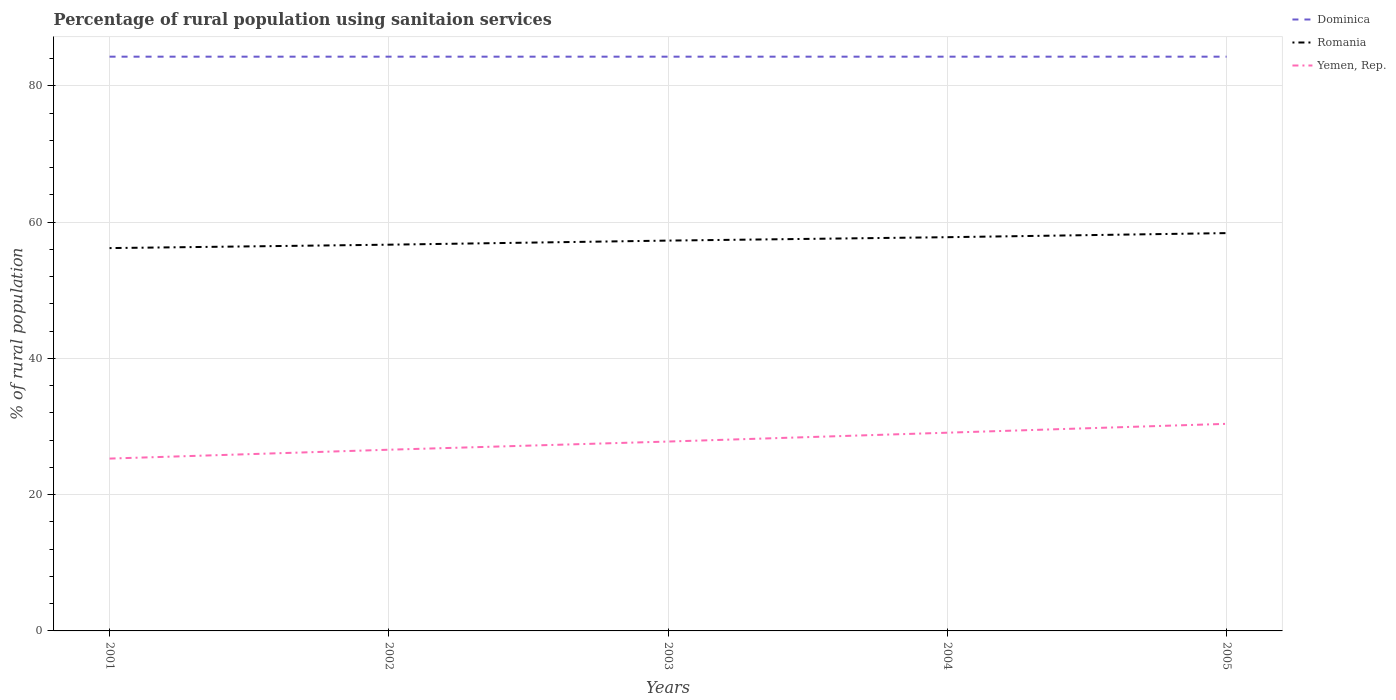Does the line corresponding to Dominica intersect with the line corresponding to Yemen, Rep.?
Your answer should be very brief. No. Is the number of lines equal to the number of legend labels?
Your response must be concise. Yes. Across all years, what is the maximum percentage of rural population using sanitaion services in Dominica?
Your answer should be compact. 84.3. What is the total percentage of rural population using sanitaion services in Yemen, Rep. in the graph?
Offer a very short reply. -3.8. What is the difference between the highest and the second highest percentage of rural population using sanitaion services in Romania?
Give a very brief answer. 2.2. Is the percentage of rural population using sanitaion services in Romania strictly greater than the percentage of rural population using sanitaion services in Yemen, Rep. over the years?
Ensure brevity in your answer.  No. Does the graph contain grids?
Ensure brevity in your answer.  Yes. Where does the legend appear in the graph?
Provide a short and direct response. Top right. How are the legend labels stacked?
Keep it short and to the point. Vertical. What is the title of the graph?
Offer a terse response. Percentage of rural population using sanitaion services. What is the label or title of the X-axis?
Make the answer very short. Years. What is the label or title of the Y-axis?
Your answer should be compact. % of rural population. What is the % of rural population of Dominica in 2001?
Give a very brief answer. 84.3. What is the % of rural population in Romania in 2001?
Offer a terse response. 56.2. What is the % of rural population in Yemen, Rep. in 2001?
Offer a very short reply. 25.3. What is the % of rural population in Dominica in 2002?
Provide a succinct answer. 84.3. What is the % of rural population in Romania in 2002?
Make the answer very short. 56.7. What is the % of rural population in Yemen, Rep. in 2002?
Offer a terse response. 26.6. What is the % of rural population in Dominica in 2003?
Give a very brief answer. 84.3. What is the % of rural population in Romania in 2003?
Your response must be concise. 57.3. What is the % of rural population of Yemen, Rep. in 2003?
Offer a very short reply. 27.8. What is the % of rural population of Dominica in 2004?
Your answer should be very brief. 84.3. What is the % of rural population of Romania in 2004?
Provide a succinct answer. 57.8. What is the % of rural population of Yemen, Rep. in 2004?
Offer a very short reply. 29.1. What is the % of rural population in Dominica in 2005?
Give a very brief answer. 84.3. What is the % of rural population of Romania in 2005?
Ensure brevity in your answer.  58.4. What is the % of rural population of Yemen, Rep. in 2005?
Your answer should be compact. 30.4. Across all years, what is the maximum % of rural population in Dominica?
Provide a short and direct response. 84.3. Across all years, what is the maximum % of rural population of Romania?
Your answer should be compact. 58.4. Across all years, what is the maximum % of rural population of Yemen, Rep.?
Your answer should be compact. 30.4. Across all years, what is the minimum % of rural population in Dominica?
Make the answer very short. 84.3. Across all years, what is the minimum % of rural population of Romania?
Your answer should be very brief. 56.2. Across all years, what is the minimum % of rural population in Yemen, Rep.?
Your response must be concise. 25.3. What is the total % of rural population of Dominica in the graph?
Offer a very short reply. 421.5. What is the total % of rural population in Romania in the graph?
Your answer should be compact. 286.4. What is the total % of rural population in Yemen, Rep. in the graph?
Provide a short and direct response. 139.2. What is the difference between the % of rural population of Dominica in 2001 and that in 2002?
Your answer should be very brief. 0. What is the difference between the % of rural population of Dominica in 2001 and that in 2003?
Provide a short and direct response. 0. What is the difference between the % of rural population of Romania in 2001 and that in 2003?
Ensure brevity in your answer.  -1.1. What is the difference between the % of rural population in Dominica in 2001 and that in 2004?
Make the answer very short. 0. What is the difference between the % of rural population in Romania in 2001 and that in 2004?
Provide a short and direct response. -1.6. What is the difference between the % of rural population in Yemen, Rep. in 2001 and that in 2004?
Make the answer very short. -3.8. What is the difference between the % of rural population in Romania in 2001 and that in 2005?
Offer a very short reply. -2.2. What is the difference between the % of rural population in Yemen, Rep. in 2001 and that in 2005?
Your answer should be very brief. -5.1. What is the difference between the % of rural population of Dominica in 2002 and that in 2003?
Provide a short and direct response. 0. What is the difference between the % of rural population of Dominica in 2002 and that in 2004?
Your answer should be compact. 0. What is the difference between the % of rural population in Dominica in 2003 and that in 2004?
Offer a very short reply. 0. What is the difference between the % of rural population of Romania in 2003 and that in 2004?
Your answer should be compact. -0.5. What is the difference between the % of rural population in Dominica in 2003 and that in 2005?
Offer a very short reply. 0. What is the difference between the % of rural population in Romania in 2003 and that in 2005?
Keep it short and to the point. -1.1. What is the difference between the % of rural population of Yemen, Rep. in 2003 and that in 2005?
Your answer should be very brief. -2.6. What is the difference between the % of rural population of Dominica in 2004 and that in 2005?
Give a very brief answer. 0. What is the difference between the % of rural population of Romania in 2004 and that in 2005?
Give a very brief answer. -0.6. What is the difference between the % of rural population in Yemen, Rep. in 2004 and that in 2005?
Your response must be concise. -1.3. What is the difference between the % of rural population in Dominica in 2001 and the % of rural population in Romania in 2002?
Give a very brief answer. 27.6. What is the difference between the % of rural population in Dominica in 2001 and the % of rural population in Yemen, Rep. in 2002?
Make the answer very short. 57.7. What is the difference between the % of rural population of Romania in 2001 and the % of rural population of Yemen, Rep. in 2002?
Your answer should be compact. 29.6. What is the difference between the % of rural population in Dominica in 2001 and the % of rural population in Yemen, Rep. in 2003?
Offer a very short reply. 56.5. What is the difference between the % of rural population of Romania in 2001 and the % of rural population of Yemen, Rep. in 2003?
Your answer should be very brief. 28.4. What is the difference between the % of rural population in Dominica in 2001 and the % of rural population in Yemen, Rep. in 2004?
Offer a terse response. 55.2. What is the difference between the % of rural population of Romania in 2001 and the % of rural population of Yemen, Rep. in 2004?
Offer a very short reply. 27.1. What is the difference between the % of rural population of Dominica in 2001 and the % of rural population of Romania in 2005?
Offer a terse response. 25.9. What is the difference between the % of rural population in Dominica in 2001 and the % of rural population in Yemen, Rep. in 2005?
Your answer should be compact. 53.9. What is the difference between the % of rural population in Romania in 2001 and the % of rural population in Yemen, Rep. in 2005?
Provide a succinct answer. 25.8. What is the difference between the % of rural population in Dominica in 2002 and the % of rural population in Romania in 2003?
Your answer should be compact. 27. What is the difference between the % of rural population in Dominica in 2002 and the % of rural population in Yemen, Rep. in 2003?
Give a very brief answer. 56.5. What is the difference between the % of rural population of Romania in 2002 and the % of rural population of Yemen, Rep. in 2003?
Keep it short and to the point. 28.9. What is the difference between the % of rural population of Dominica in 2002 and the % of rural population of Yemen, Rep. in 2004?
Offer a very short reply. 55.2. What is the difference between the % of rural population in Romania in 2002 and the % of rural population in Yemen, Rep. in 2004?
Provide a succinct answer. 27.6. What is the difference between the % of rural population in Dominica in 2002 and the % of rural population in Romania in 2005?
Give a very brief answer. 25.9. What is the difference between the % of rural population in Dominica in 2002 and the % of rural population in Yemen, Rep. in 2005?
Provide a short and direct response. 53.9. What is the difference between the % of rural population in Romania in 2002 and the % of rural population in Yemen, Rep. in 2005?
Offer a terse response. 26.3. What is the difference between the % of rural population of Dominica in 2003 and the % of rural population of Romania in 2004?
Make the answer very short. 26.5. What is the difference between the % of rural population in Dominica in 2003 and the % of rural population in Yemen, Rep. in 2004?
Keep it short and to the point. 55.2. What is the difference between the % of rural population in Romania in 2003 and the % of rural population in Yemen, Rep. in 2004?
Ensure brevity in your answer.  28.2. What is the difference between the % of rural population of Dominica in 2003 and the % of rural population of Romania in 2005?
Provide a succinct answer. 25.9. What is the difference between the % of rural population in Dominica in 2003 and the % of rural population in Yemen, Rep. in 2005?
Provide a short and direct response. 53.9. What is the difference between the % of rural population in Romania in 2003 and the % of rural population in Yemen, Rep. in 2005?
Your answer should be very brief. 26.9. What is the difference between the % of rural population of Dominica in 2004 and the % of rural population of Romania in 2005?
Your answer should be compact. 25.9. What is the difference between the % of rural population in Dominica in 2004 and the % of rural population in Yemen, Rep. in 2005?
Make the answer very short. 53.9. What is the difference between the % of rural population in Romania in 2004 and the % of rural population in Yemen, Rep. in 2005?
Give a very brief answer. 27.4. What is the average % of rural population of Dominica per year?
Give a very brief answer. 84.3. What is the average % of rural population of Romania per year?
Offer a terse response. 57.28. What is the average % of rural population in Yemen, Rep. per year?
Offer a terse response. 27.84. In the year 2001, what is the difference between the % of rural population in Dominica and % of rural population in Romania?
Provide a short and direct response. 28.1. In the year 2001, what is the difference between the % of rural population of Dominica and % of rural population of Yemen, Rep.?
Provide a short and direct response. 59. In the year 2001, what is the difference between the % of rural population in Romania and % of rural population in Yemen, Rep.?
Offer a terse response. 30.9. In the year 2002, what is the difference between the % of rural population of Dominica and % of rural population of Romania?
Your answer should be very brief. 27.6. In the year 2002, what is the difference between the % of rural population in Dominica and % of rural population in Yemen, Rep.?
Your response must be concise. 57.7. In the year 2002, what is the difference between the % of rural population in Romania and % of rural population in Yemen, Rep.?
Make the answer very short. 30.1. In the year 2003, what is the difference between the % of rural population in Dominica and % of rural population in Romania?
Provide a short and direct response. 27. In the year 2003, what is the difference between the % of rural population of Dominica and % of rural population of Yemen, Rep.?
Make the answer very short. 56.5. In the year 2003, what is the difference between the % of rural population in Romania and % of rural population in Yemen, Rep.?
Give a very brief answer. 29.5. In the year 2004, what is the difference between the % of rural population of Dominica and % of rural population of Romania?
Your response must be concise. 26.5. In the year 2004, what is the difference between the % of rural population in Dominica and % of rural population in Yemen, Rep.?
Your response must be concise. 55.2. In the year 2004, what is the difference between the % of rural population in Romania and % of rural population in Yemen, Rep.?
Offer a terse response. 28.7. In the year 2005, what is the difference between the % of rural population of Dominica and % of rural population of Romania?
Your answer should be compact. 25.9. In the year 2005, what is the difference between the % of rural population in Dominica and % of rural population in Yemen, Rep.?
Make the answer very short. 53.9. In the year 2005, what is the difference between the % of rural population of Romania and % of rural population of Yemen, Rep.?
Your response must be concise. 28. What is the ratio of the % of rural population of Dominica in 2001 to that in 2002?
Your answer should be compact. 1. What is the ratio of the % of rural population in Yemen, Rep. in 2001 to that in 2002?
Your answer should be compact. 0.95. What is the ratio of the % of rural population in Dominica in 2001 to that in 2003?
Ensure brevity in your answer.  1. What is the ratio of the % of rural population in Romania in 2001 to that in 2003?
Make the answer very short. 0.98. What is the ratio of the % of rural population of Yemen, Rep. in 2001 to that in 2003?
Offer a very short reply. 0.91. What is the ratio of the % of rural population of Dominica in 2001 to that in 2004?
Your response must be concise. 1. What is the ratio of the % of rural population in Romania in 2001 to that in 2004?
Keep it short and to the point. 0.97. What is the ratio of the % of rural population in Yemen, Rep. in 2001 to that in 2004?
Offer a very short reply. 0.87. What is the ratio of the % of rural population of Dominica in 2001 to that in 2005?
Ensure brevity in your answer.  1. What is the ratio of the % of rural population of Romania in 2001 to that in 2005?
Provide a short and direct response. 0.96. What is the ratio of the % of rural population in Yemen, Rep. in 2001 to that in 2005?
Give a very brief answer. 0.83. What is the ratio of the % of rural population of Yemen, Rep. in 2002 to that in 2003?
Your answer should be compact. 0.96. What is the ratio of the % of rural population of Dominica in 2002 to that in 2004?
Provide a short and direct response. 1. What is the ratio of the % of rural population of Romania in 2002 to that in 2004?
Offer a terse response. 0.98. What is the ratio of the % of rural population of Yemen, Rep. in 2002 to that in 2004?
Offer a very short reply. 0.91. What is the ratio of the % of rural population in Dominica in 2002 to that in 2005?
Your answer should be very brief. 1. What is the ratio of the % of rural population in Romania in 2002 to that in 2005?
Offer a terse response. 0.97. What is the ratio of the % of rural population of Romania in 2003 to that in 2004?
Ensure brevity in your answer.  0.99. What is the ratio of the % of rural population in Yemen, Rep. in 2003 to that in 2004?
Provide a succinct answer. 0.96. What is the ratio of the % of rural population of Dominica in 2003 to that in 2005?
Give a very brief answer. 1. What is the ratio of the % of rural population in Romania in 2003 to that in 2005?
Your answer should be compact. 0.98. What is the ratio of the % of rural population of Yemen, Rep. in 2003 to that in 2005?
Provide a succinct answer. 0.91. What is the ratio of the % of rural population of Romania in 2004 to that in 2005?
Make the answer very short. 0.99. What is the ratio of the % of rural population of Yemen, Rep. in 2004 to that in 2005?
Offer a terse response. 0.96. What is the difference between the highest and the second highest % of rural population in Dominica?
Keep it short and to the point. 0. What is the difference between the highest and the second highest % of rural population in Romania?
Your answer should be very brief. 0.6. What is the difference between the highest and the lowest % of rural population in Romania?
Provide a short and direct response. 2.2. What is the difference between the highest and the lowest % of rural population of Yemen, Rep.?
Provide a short and direct response. 5.1. 